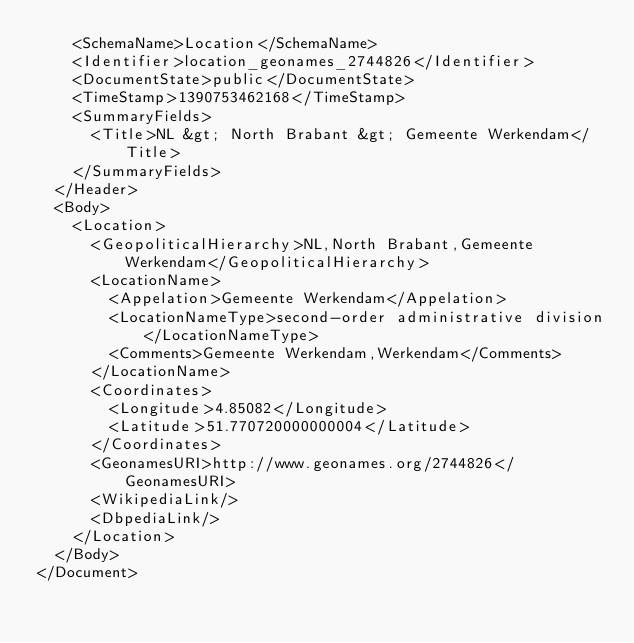Convert code to text. <code><loc_0><loc_0><loc_500><loc_500><_XML_>    <SchemaName>Location</SchemaName>
    <Identifier>location_geonames_2744826</Identifier>
    <DocumentState>public</DocumentState>
    <TimeStamp>1390753462168</TimeStamp>
    <SummaryFields>
      <Title>NL &gt; North Brabant &gt; Gemeente Werkendam</Title>
    </SummaryFields>
  </Header>
  <Body>
    <Location>
      <GeopoliticalHierarchy>NL,North Brabant,Gemeente Werkendam</GeopoliticalHierarchy>
      <LocationName>
        <Appelation>Gemeente Werkendam</Appelation>
        <LocationNameType>second-order administrative division</LocationNameType>
        <Comments>Gemeente Werkendam,Werkendam</Comments>
      </LocationName>
      <Coordinates>
        <Longitude>4.85082</Longitude>
        <Latitude>51.770720000000004</Latitude>
      </Coordinates>
      <GeonamesURI>http://www.geonames.org/2744826</GeonamesURI>
      <WikipediaLink/>
      <DbpediaLink/>
    </Location>
  </Body>
</Document>
</code> 